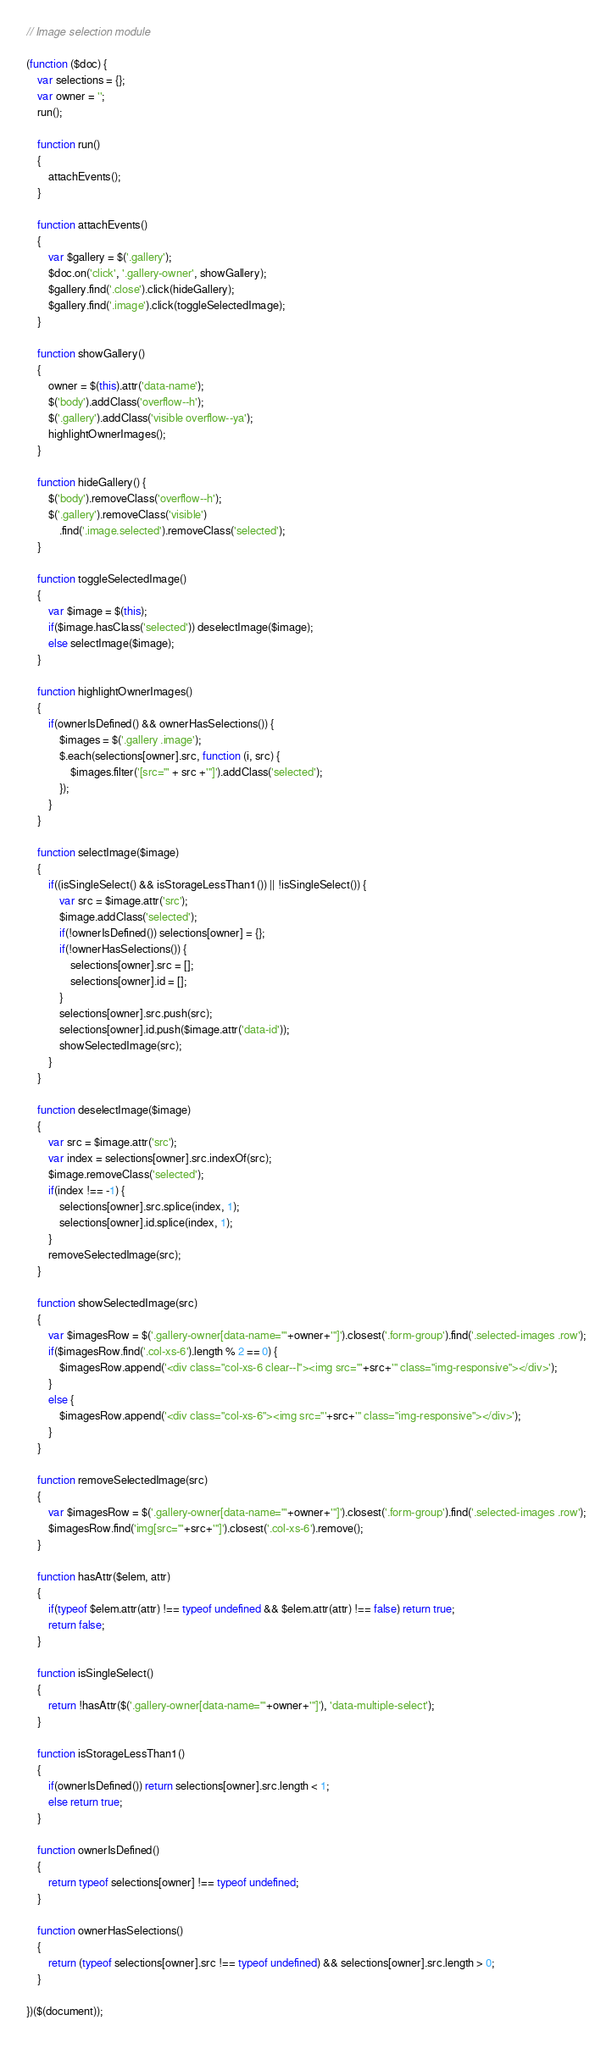<code> <loc_0><loc_0><loc_500><loc_500><_JavaScript_>// Image selection module

(function ($doc) {
	var selections = {};
	var owner = '';
	run();

	function run()
	{
		attachEvents();
	}

	function attachEvents()
	{
		var $gallery = $('.gallery');
		$doc.on('click', '.gallery-owner', showGallery);
		$gallery.find('.close').click(hideGallery);
		$gallery.find('.image').click(toggleSelectedImage);
	}

	function showGallery()
	{
		owner = $(this).attr('data-name');
		$('body').addClass('overflow--h');
		$('.gallery').addClass('visible overflow--ya');
		highlightOwnerImages();
	}

	function hideGallery() {
		$('body').removeClass('overflow--h');
		$('.gallery').removeClass('visible')
			.find('.image.selected').removeClass('selected');
	}

	function toggleSelectedImage()
	{
		var $image = $(this);
		if($image.hasClass('selected')) deselectImage($image);
		else selectImage($image);
	}

	function highlightOwnerImages()
	{
		if(ownerIsDefined() && ownerHasSelections()) {
			$images = $('.gallery .image');
			$.each(selections[owner].src, function (i, src) {
				$images.filter('[src="' + src +'"]').addClass('selected');
			});
		}
	}
	
	function selectImage($image)
	{
		if((isSingleSelect() && isStorageLessThan1()) || !isSingleSelect()) {
			var src = $image.attr('src');
			$image.addClass('selected');
			if(!ownerIsDefined()) selections[owner] = {};
			if(!ownerHasSelections()) {
				selections[owner].src = [];
				selections[owner].id = [];
			}
			selections[owner].src.push(src);
			selections[owner].id.push($image.attr('data-id'));
			showSelectedImage(src);
		}
	}

	function deselectImage($image)
	{
		var src = $image.attr('src');
		var index = selections[owner].src.indexOf(src);
		$image.removeClass('selected');
		if(index !== -1) {
			selections[owner].src.splice(index, 1);
			selections[owner].id.splice(index, 1);
		}
		removeSelectedImage(src);
	}

	function showSelectedImage(src)
	{
		var $imagesRow = $('.gallery-owner[data-name="'+owner+'"]').closest('.form-group').find('.selected-images .row');
		if($imagesRow.find('.col-xs-6').length % 2 == 0) {
			$imagesRow.append('<div class="col-xs-6 clear--l"><img src="'+src+'" class="img-responsive"></div>');
		}
		else {
			$imagesRow.append('<div class="col-xs-6"><img src="'+src+'" class="img-responsive"></div>');
		}
	}

	function removeSelectedImage(src)
	{
		var $imagesRow = $('.gallery-owner[data-name="'+owner+'"]').closest('.form-group').find('.selected-images .row');
		$imagesRow.find('img[src="'+src+'"]').closest('.col-xs-6').remove();
	}

	function hasAttr($elem, attr)
	{
		if(typeof $elem.attr(attr) !== typeof undefined && $elem.attr(attr) !== false) return true;
		return false;
	}

	function isSingleSelect()
	{
		return !hasAttr($('.gallery-owner[data-name="'+owner+'"]'), 'data-multiple-select');
	}

	function isStorageLessThan1()
	{
		if(ownerIsDefined()) return selections[owner].src.length < 1;
		else return true;
	}

	function ownerIsDefined()
	{
		return typeof selections[owner] !== typeof undefined;
	}

	function ownerHasSelections()
	{
		return (typeof selections[owner].src !== typeof undefined) && selections[owner].src.length > 0;
	}

})($(document));</code> 